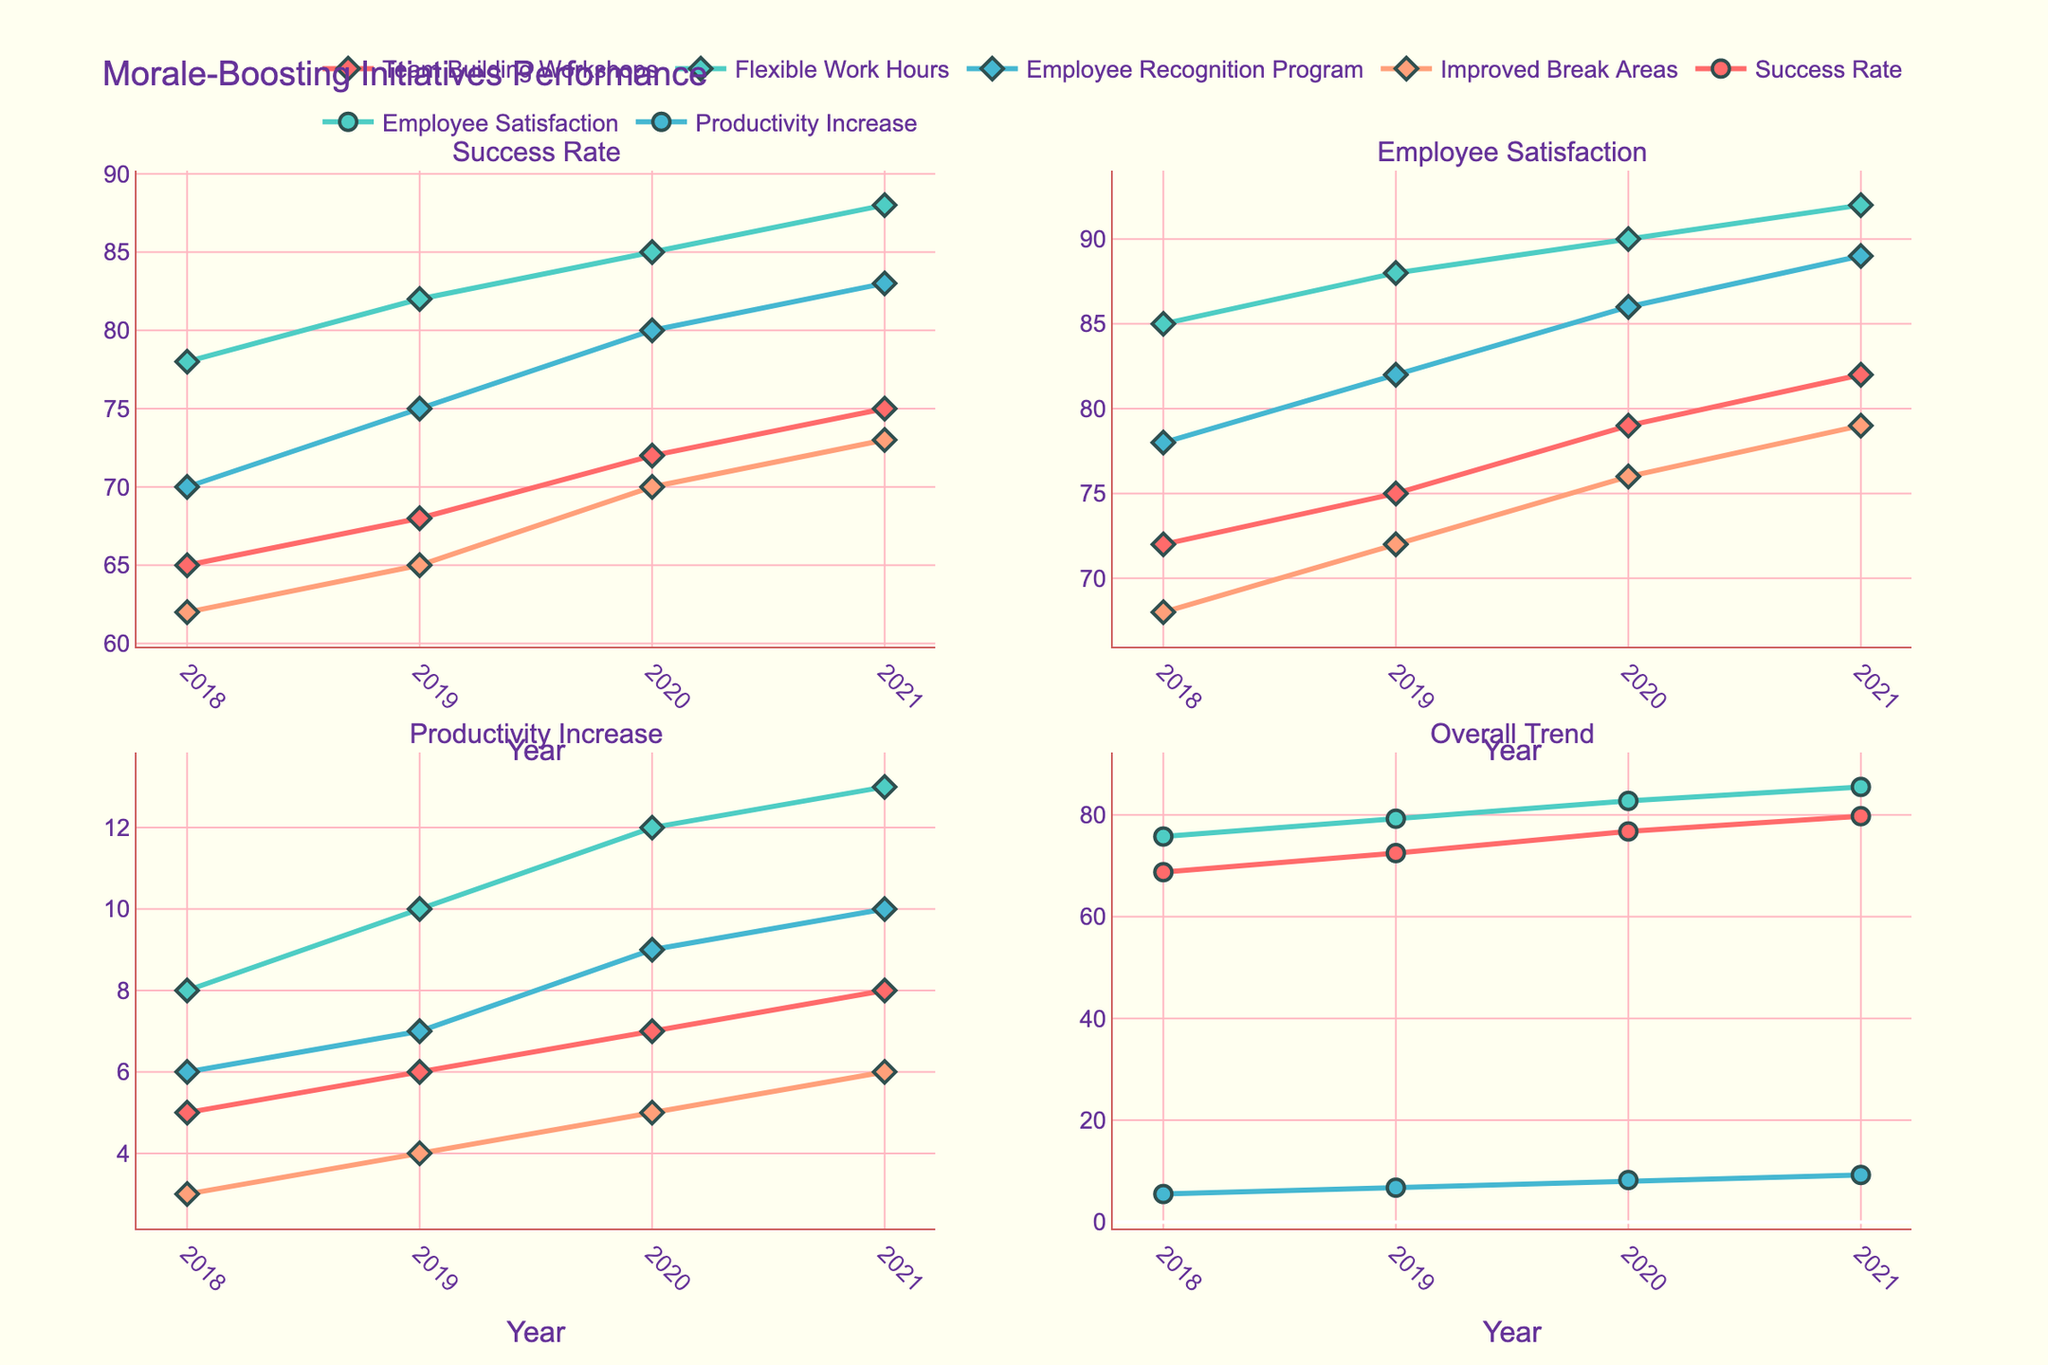What is the adoption rate for the medical sector in the year 2025? Look at the Medical subplot and find the corresponding data point for the year 2025.
Answer: 2.1% What is the title of the figure? The title is usually placed at the top of the figure and provides a summary of what the figure represents.
Answer: Estimated Global Adoption Rates of Brain-Computer Interfaces Which sector has the highest adoption rate in 2045? Compare the adoption rates of all sectors in 2045 by examining each subplot.
Answer: Research How many sectors are represented in the figure? Count the number of subplots, as each subplot represents a different sector.
Answer: 5 What is the average adoption rate of the gaming sector over the years listed? Add the adoption rates of the gaming sector for the years 2025, 2030, 2035, 2040, 2045, and 2050, then divide by the number of years. Calculation: (0.8 + 2.6 + 6.5 + 12.3 + 19.8 + 28.4) / 6 = 11.4
Answer: 11.4% Which sector has a lower adoption rate in 2050 compared to the military sector in 2030? Compare the adoption rate of the military sector in 2030 to the adoption rates of all sectors in 2050 by examining each subplot.
Answer: None What is the sum of adoption rates for all sectors in 2030? Add up the adoption rates for each sector in 2030: Medical (5.7) + Military (3.9) + Gaming (2.6) + Productivity (1.4) + Research (7.8).
Answer: 21.4% Which sector shows the most rapid growth between 2025 and 2050? Look at the slopes of the lines in each subplot, the sector with the steepest slope indicates the most rapid growth.
Answer: Research How does the adoption rate of productivity sector in 2040 compare to the medical sector in 2025? Look at both adoption rates and determine if one is greater, lesser, or if they are equal. Compare 8.2% (productivity in 2040) with 2.1% (medical in 2025).
Answer: Higher What is the difference in adoption rates for the research sector between 2035 and 2050? Subtract the adoption rate for the research sector in 2035 (14.6) from the rate in 2050 (42.1).
Answer: 27.5 